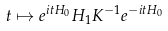<formula> <loc_0><loc_0><loc_500><loc_500>t \mapsto e ^ { i t H _ { 0 } } H _ { 1 } K ^ { - 1 } e ^ { - i t H _ { 0 } }</formula> 